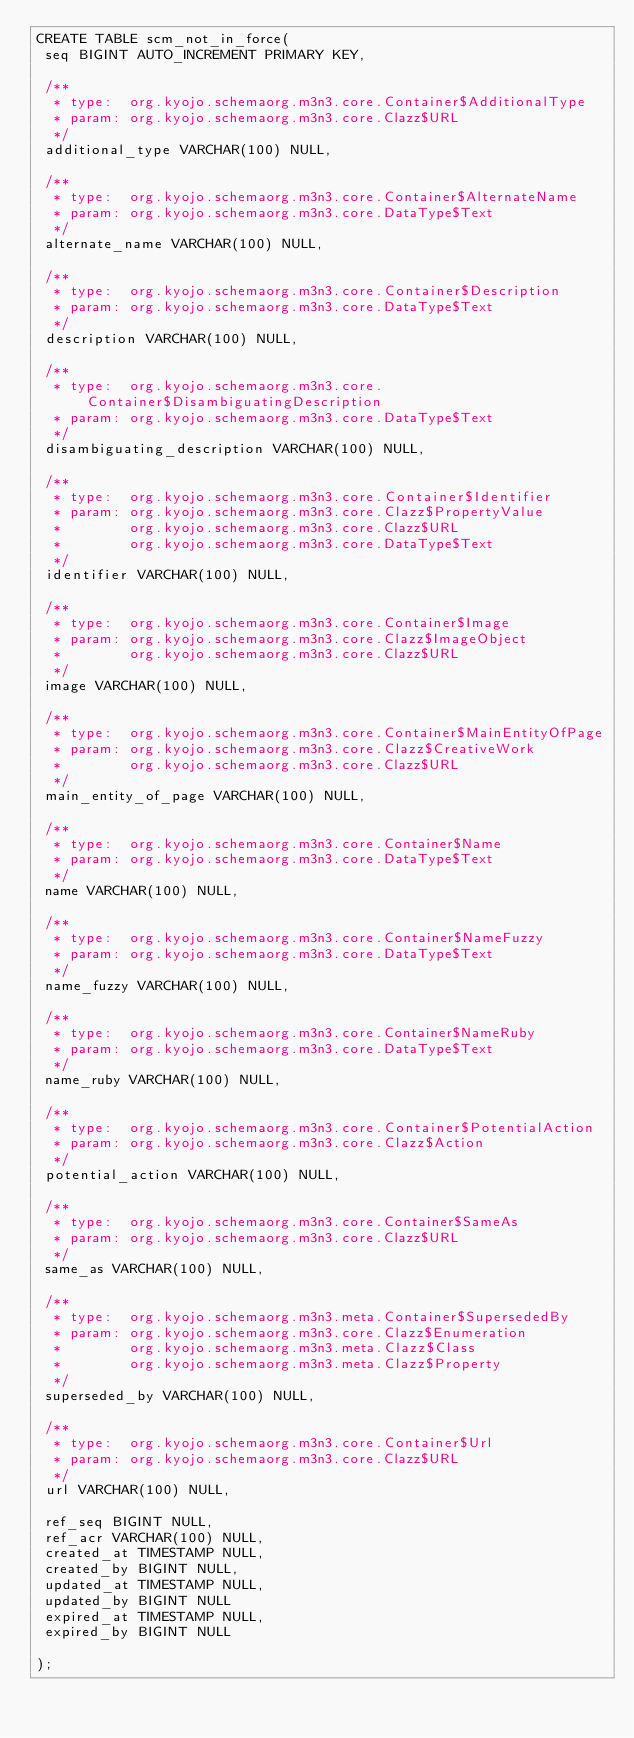Convert code to text. <code><loc_0><loc_0><loc_500><loc_500><_SQL_>CREATE TABLE scm_not_in_force(
 seq BIGINT AUTO_INCREMENT PRIMARY KEY,

 /**
  * type:  org.kyojo.schemaorg.m3n3.core.Container$AdditionalType
  * param: org.kyojo.schemaorg.m3n3.core.Clazz$URL
  */
 additional_type VARCHAR(100) NULL,

 /**
  * type:  org.kyojo.schemaorg.m3n3.core.Container$AlternateName
  * param: org.kyojo.schemaorg.m3n3.core.DataType$Text
  */
 alternate_name VARCHAR(100) NULL,

 /**
  * type:  org.kyojo.schemaorg.m3n3.core.Container$Description
  * param: org.kyojo.schemaorg.m3n3.core.DataType$Text
  */
 description VARCHAR(100) NULL,

 /**
  * type:  org.kyojo.schemaorg.m3n3.core.Container$DisambiguatingDescription
  * param: org.kyojo.schemaorg.m3n3.core.DataType$Text
  */
 disambiguating_description VARCHAR(100) NULL,

 /**
  * type:  org.kyojo.schemaorg.m3n3.core.Container$Identifier
  * param: org.kyojo.schemaorg.m3n3.core.Clazz$PropertyValue
  *        org.kyojo.schemaorg.m3n3.core.Clazz$URL
  *        org.kyojo.schemaorg.m3n3.core.DataType$Text
  */
 identifier VARCHAR(100) NULL,

 /**
  * type:  org.kyojo.schemaorg.m3n3.core.Container$Image
  * param: org.kyojo.schemaorg.m3n3.core.Clazz$ImageObject
  *        org.kyojo.schemaorg.m3n3.core.Clazz$URL
  */
 image VARCHAR(100) NULL,

 /**
  * type:  org.kyojo.schemaorg.m3n3.core.Container$MainEntityOfPage
  * param: org.kyojo.schemaorg.m3n3.core.Clazz$CreativeWork
  *        org.kyojo.schemaorg.m3n3.core.Clazz$URL
  */
 main_entity_of_page VARCHAR(100) NULL,

 /**
  * type:  org.kyojo.schemaorg.m3n3.core.Container$Name
  * param: org.kyojo.schemaorg.m3n3.core.DataType$Text
  */
 name VARCHAR(100) NULL,

 /**
  * type:  org.kyojo.schemaorg.m3n3.core.Container$NameFuzzy
  * param: org.kyojo.schemaorg.m3n3.core.DataType$Text
  */
 name_fuzzy VARCHAR(100) NULL,

 /**
  * type:  org.kyojo.schemaorg.m3n3.core.Container$NameRuby
  * param: org.kyojo.schemaorg.m3n3.core.DataType$Text
  */
 name_ruby VARCHAR(100) NULL,

 /**
  * type:  org.kyojo.schemaorg.m3n3.core.Container$PotentialAction
  * param: org.kyojo.schemaorg.m3n3.core.Clazz$Action
  */
 potential_action VARCHAR(100) NULL,

 /**
  * type:  org.kyojo.schemaorg.m3n3.core.Container$SameAs
  * param: org.kyojo.schemaorg.m3n3.core.Clazz$URL
  */
 same_as VARCHAR(100) NULL,

 /**
  * type:  org.kyojo.schemaorg.m3n3.meta.Container$SupersededBy
  * param: org.kyojo.schemaorg.m3n3.core.Clazz$Enumeration
  *        org.kyojo.schemaorg.m3n3.meta.Clazz$Class
  *        org.kyojo.schemaorg.m3n3.meta.Clazz$Property
  */
 superseded_by VARCHAR(100) NULL,

 /**
  * type:  org.kyojo.schemaorg.m3n3.core.Container$Url
  * param: org.kyojo.schemaorg.m3n3.core.Clazz$URL
  */
 url VARCHAR(100) NULL,

 ref_seq BIGINT NULL,
 ref_acr VARCHAR(100) NULL,
 created_at TIMESTAMP NULL,
 created_by BIGINT NULL,
 updated_at TIMESTAMP NULL,
 updated_by BIGINT NULL
 expired_at TIMESTAMP NULL,
 expired_by BIGINT NULL

);</code> 